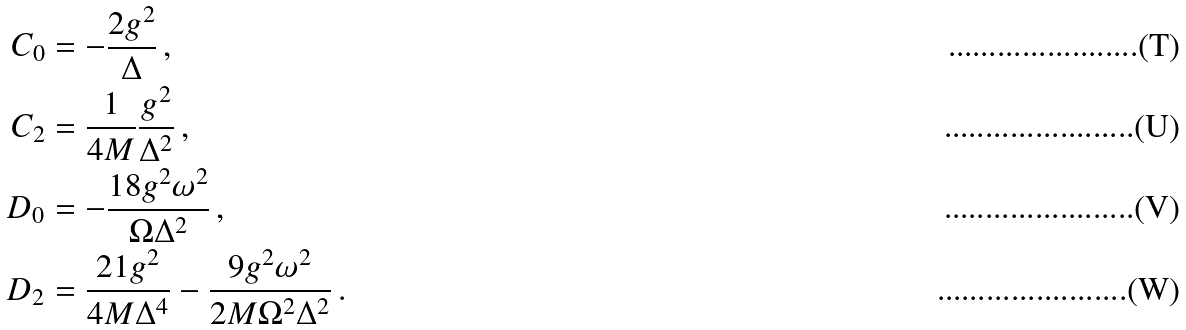<formula> <loc_0><loc_0><loc_500><loc_500>C _ { 0 } & = - \frac { 2 g ^ { 2 } } { \Delta } \, , \\ C _ { 2 } & = \frac { 1 } { 4 M } \frac { g ^ { 2 } } { \Delta ^ { 2 } } \, , \\ D _ { 0 } & = - \frac { 1 8 g ^ { 2 } \omega ^ { 2 } } { \Omega \Delta ^ { 2 } } \, , \\ D _ { 2 } & = \frac { 2 1 g ^ { 2 } } { 4 M \Delta ^ { 4 } } - \frac { 9 g ^ { 2 } \omega ^ { 2 } } { 2 M \Omega ^ { 2 } \Delta ^ { 2 } } \, .</formula> 